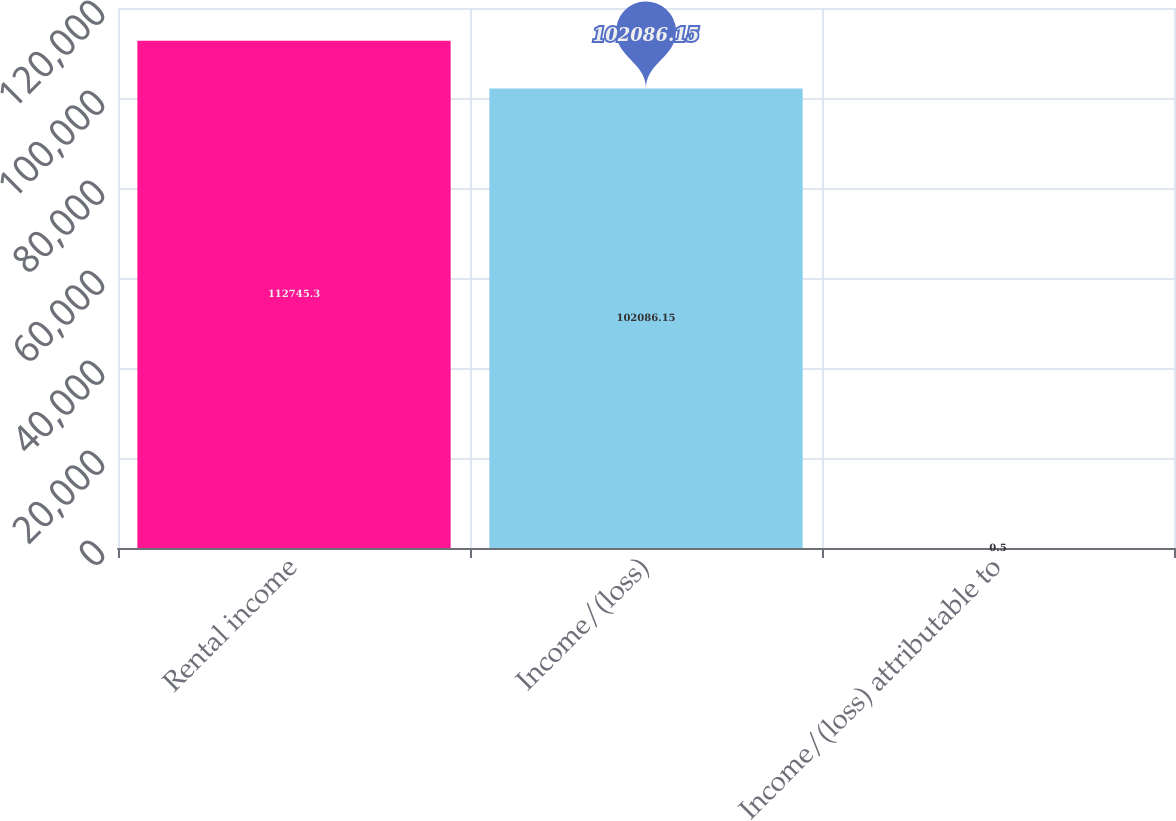Convert chart. <chart><loc_0><loc_0><loc_500><loc_500><bar_chart><fcel>Rental income<fcel>Income/(loss)<fcel>Income/(loss) attributable to<nl><fcel>112745<fcel>102086<fcel>0.5<nl></chart> 